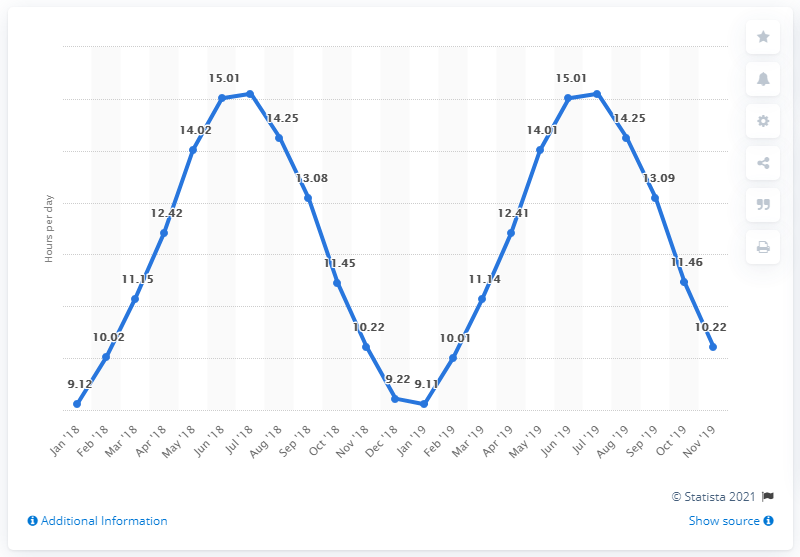Outline some significant characteristics in this image. On the 1st of July, a total of 15.1 hours were counted. 